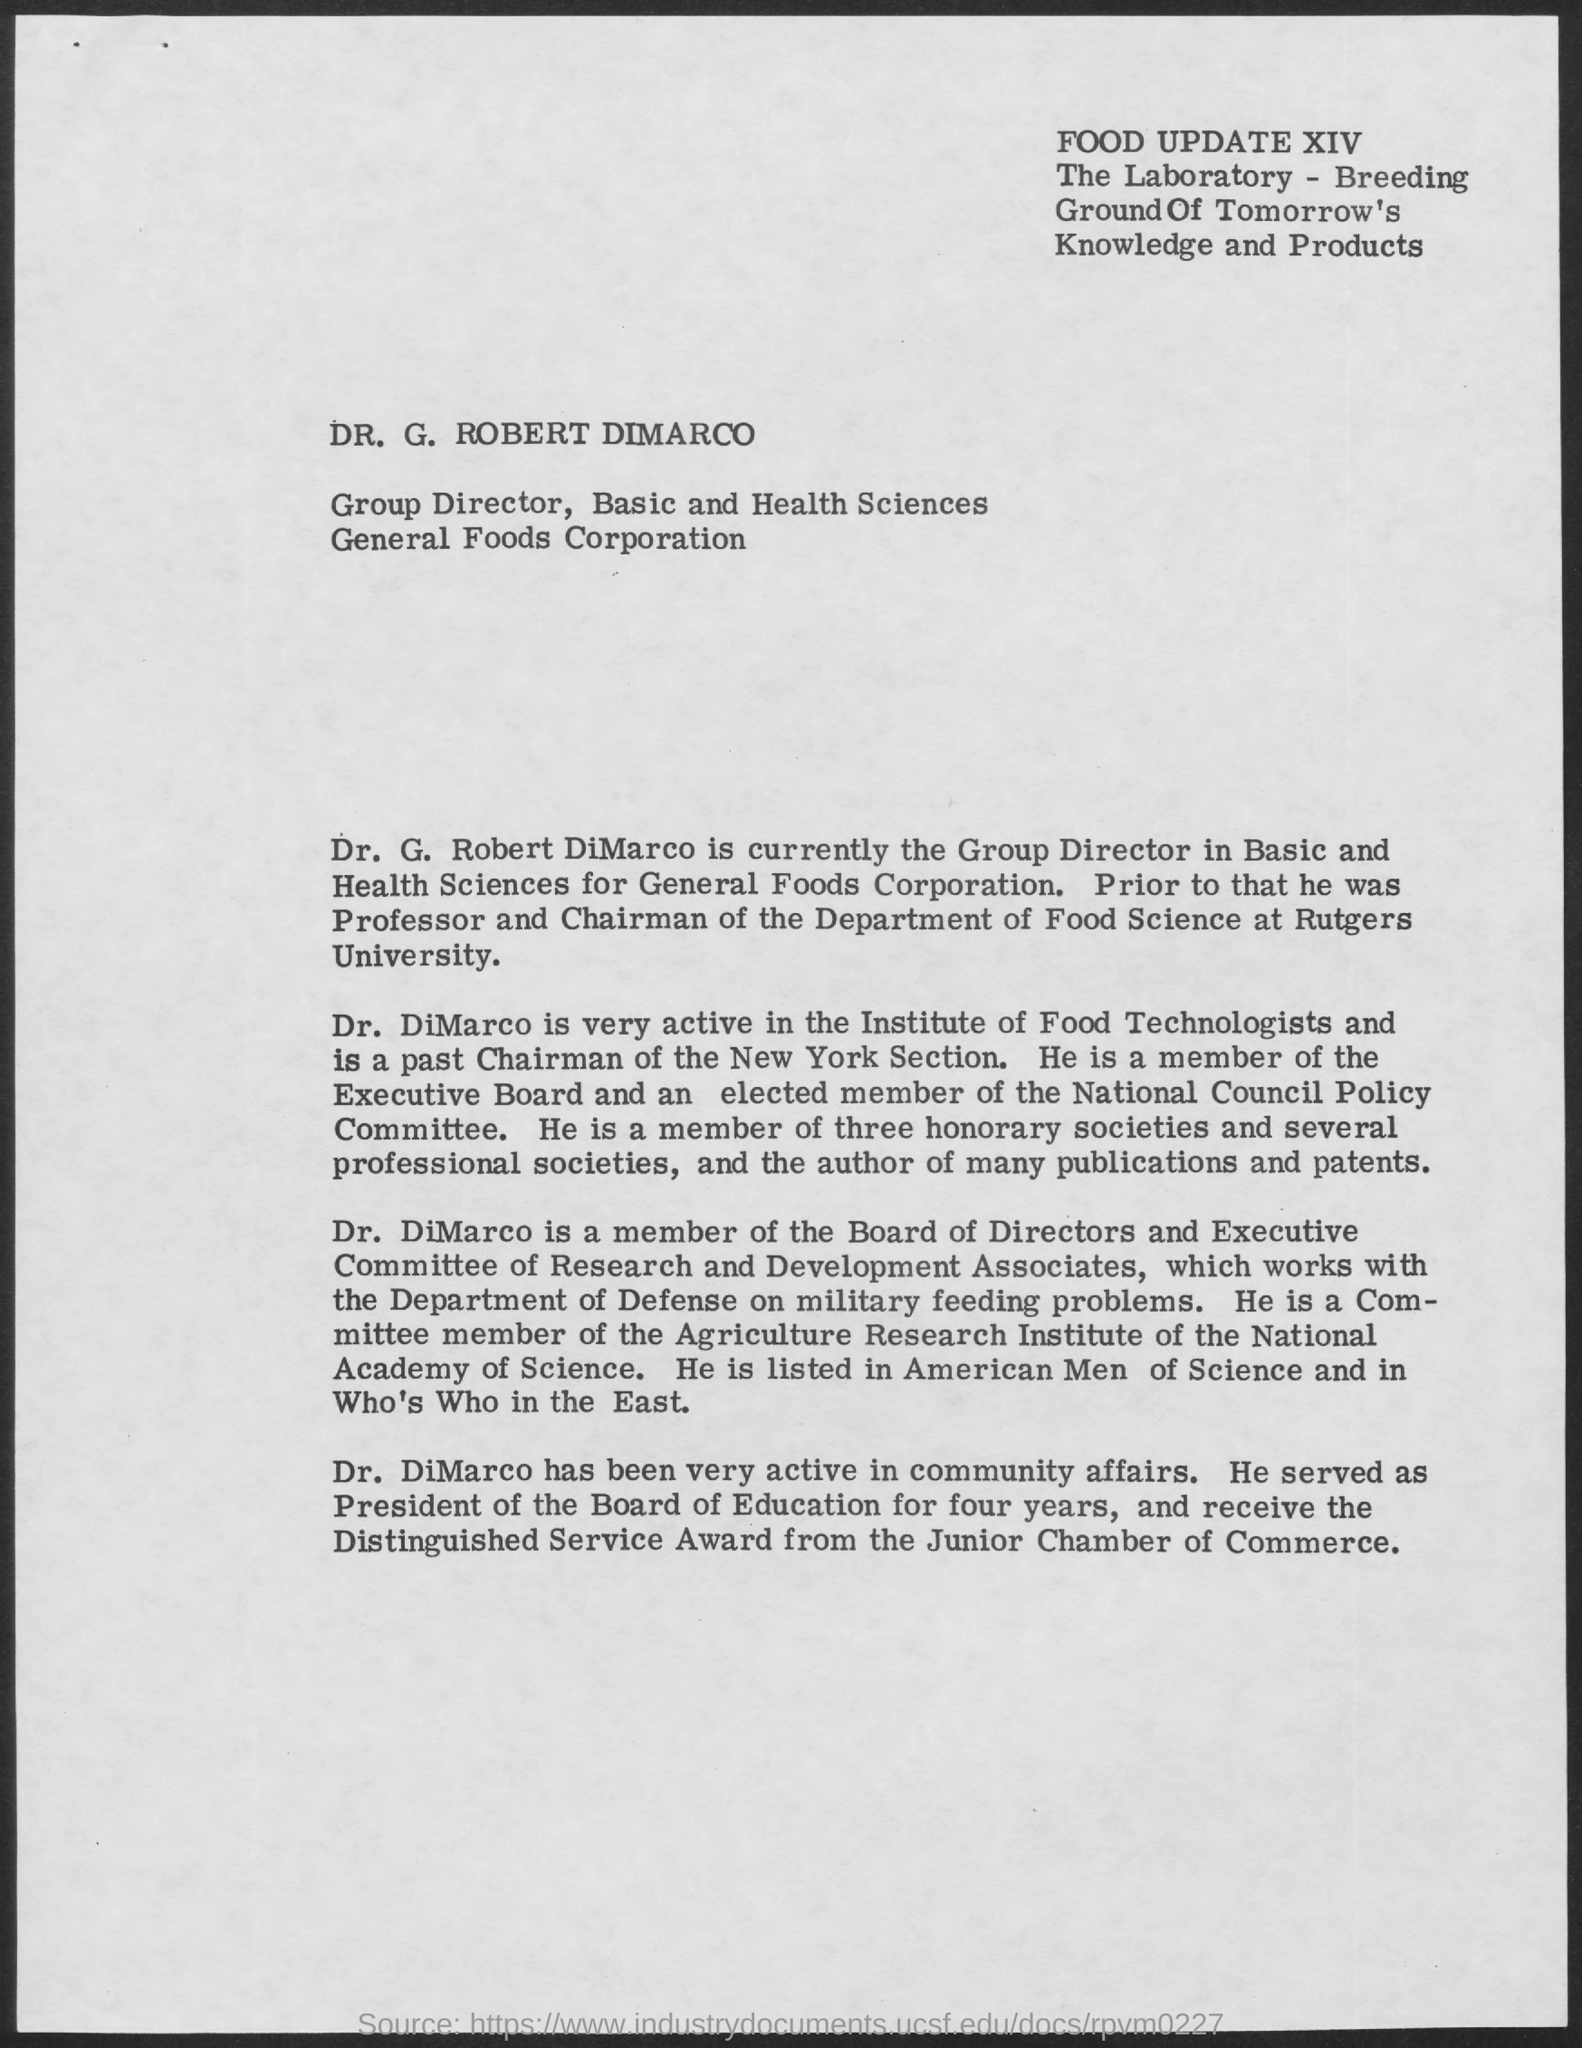Mention a couple of crucial points in this snapshot. Dr. DiMarco received the Distinguished Service Award. Dr. G. Robert Dimarco is the Group Director. The award given to Dr. DiMarco was from the Junior Chamber of Commerce. 